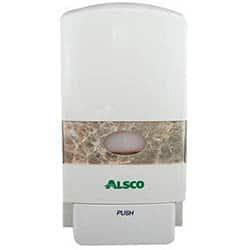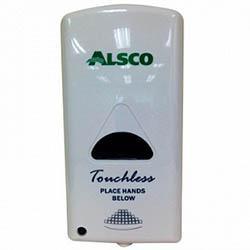The first image is the image on the left, the second image is the image on the right. Given the left and right images, does the statement "The cylindrical dispenser in one of the images has a thin tube on the spout." hold true? Answer yes or no. No. 